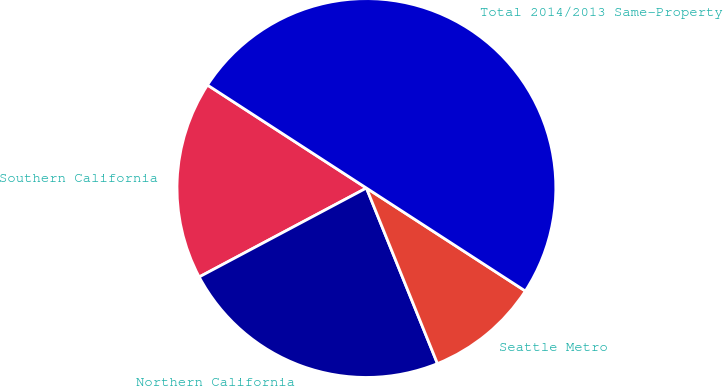Convert chart to OTSL. <chart><loc_0><loc_0><loc_500><loc_500><pie_chart><fcel>Southern California<fcel>Northern California<fcel>Seattle Metro<fcel>Total 2014/2013 Same-Property<nl><fcel>16.93%<fcel>23.34%<fcel>9.73%<fcel>50.0%<nl></chart> 